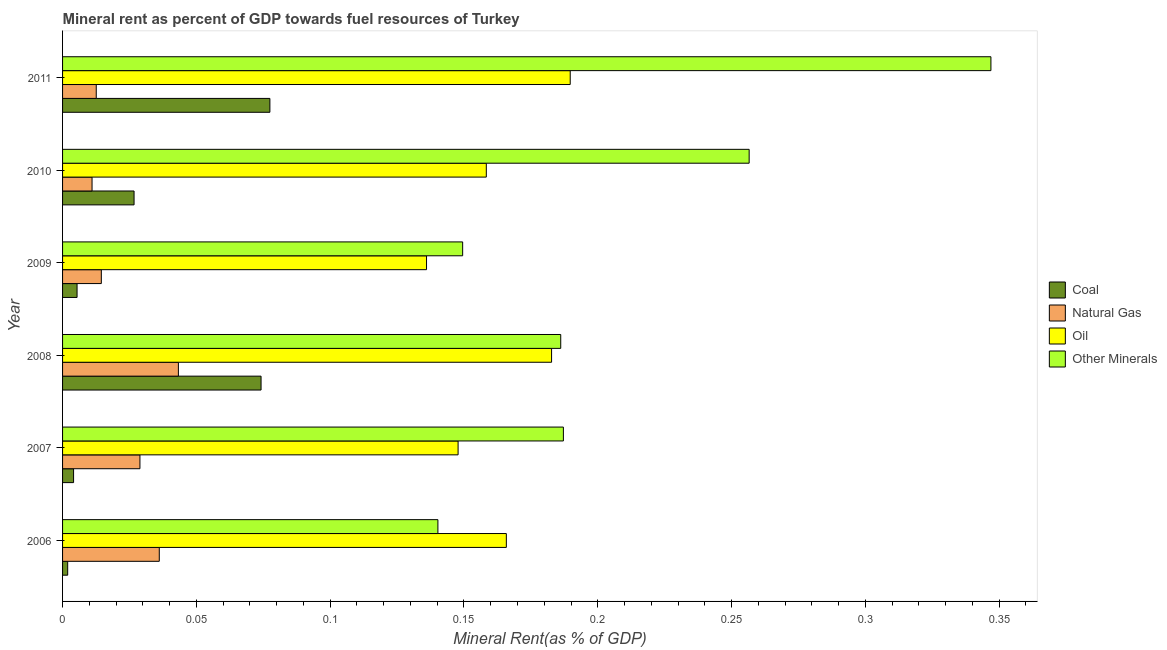How many different coloured bars are there?
Your answer should be very brief. 4. How many groups of bars are there?
Offer a terse response. 6. Are the number of bars per tick equal to the number of legend labels?
Give a very brief answer. Yes. Are the number of bars on each tick of the Y-axis equal?
Provide a short and direct response. Yes. How many bars are there on the 4th tick from the top?
Your answer should be very brief. 4. How many bars are there on the 3rd tick from the bottom?
Keep it short and to the point. 4. What is the  rent of other minerals in 2009?
Make the answer very short. 0.15. Across all years, what is the maximum coal rent?
Provide a succinct answer. 0.08. Across all years, what is the minimum  rent of other minerals?
Your answer should be compact. 0.14. In which year was the coal rent maximum?
Keep it short and to the point. 2011. What is the total coal rent in the graph?
Make the answer very short. 0.19. What is the difference between the oil rent in 2008 and that in 2011?
Keep it short and to the point. -0.01. What is the difference between the  rent of other minerals in 2009 and the coal rent in 2006?
Ensure brevity in your answer.  0.15. What is the average natural gas rent per year?
Keep it short and to the point. 0.02. In the year 2008, what is the difference between the  rent of other minerals and coal rent?
Ensure brevity in your answer.  0.11. What is the ratio of the coal rent in 2010 to that in 2011?
Offer a very short reply. 0.34. Is the coal rent in 2007 less than that in 2011?
Your answer should be very brief. Yes. What is the difference between the highest and the second highest  rent of other minerals?
Your response must be concise. 0.09. Is it the case that in every year, the sum of the coal rent and  rent of other minerals is greater than the sum of oil rent and natural gas rent?
Provide a succinct answer. No. What does the 3rd bar from the top in 2011 represents?
Offer a terse response. Natural Gas. What does the 1st bar from the bottom in 2011 represents?
Offer a terse response. Coal. How many bars are there?
Offer a very short reply. 24. Are all the bars in the graph horizontal?
Give a very brief answer. Yes. How many years are there in the graph?
Provide a short and direct response. 6. What is the difference between two consecutive major ticks on the X-axis?
Your answer should be compact. 0.05. Does the graph contain grids?
Ensure brevity in your answer.  No. Where does the legend appear in the graph?
Provide a succinct answer. Center right. How many legend labels are there?
Keep it short and to the point. 4. What is the title of the graph?
Your answer should be compact. Mineral rent as percent of GDP towards fuel resources of Turkey. What is the label or title of the X-axis?
Provide a short and direct response. Mineral Rent(as % of GDP). What is the Mineral Rent(as % of GDP) of Coal in 2006?
Offer a terse response. 0. What is the Mineral Rent(as % of GDP) in Natural Gas in 2006?
Offer a terse response. 0.04. What is the Mineral Rent(as % of GDP) of Oil in 2006?
Provide a short and direct response. 0.17. What is the Mineral Rent(as % of GDP) of Other Minerals in 2006?
Provide a succinct answer. 0.14. What is the Mineral Rent(as % of GDP) of Coal in 2007?
Offer a terse response. 0. What is the Mineral Rent(as % of GDP) in Natural Gas in 2007?
Make the answer very short. 0.03. What is the Mineral Rent(as % of GDP) in Oil in 2007?
Your answer should be very brief. 0.15. What is the Mineral Rent(as % of GDP) in Other Minerals in 2007?
Your response must be concise. 0.19. What is the Mineral Rent(as % of GDP) in Coal in 2008?
Provide a short and direct response. 0.07. What is the Mineral Rent(as % of GDP) of Natural Gas in 2008?
Your answer should be very brief. 0.04. What is the Mineral Rent(as % of GDP) of Oil in 2008?
Make the answer very short. 0.18. What is the Mineral Rent(as % of GDP) in Other Minerals in 2008?
Ensure brevity in your answer.  0.19. What is the Mineral Rent(as % of GDP) in Coal in 2009?
Give a very brief answer. 0.01. What is the Mineral Rent(as % of GDP) of Natural Gas in 2009?
Ensure brevity in your answer.  0.01. What is the Mineral Rent(as % of GDP) in Oil in 2009?
Make the answer very short. 0.14. What is the Mineral Rent(as % of GDP) of Other Minerals in 2009?
Your answer should be very brief. 0.15. What is the Mineral Rent(as % of GDP) in Coal in 2010?
Your answer should be compact. 0.03. What is the Mineral Rent(as % of GDP) in Natural Gas in 2010?
Make the answer very short. 0.01. What is the Mineral Rent(as % of GDP) in Oil in 2010?
Give a very brief answer. 0.16. What is the Mineral Rent(as % of GDP) in Other Minerals in 2010?
Make the answer very short. 0.26. What is the Mineral Rent(as % of GDP) in Coal in 2011?
Your answer should be very brief. 0.08. What is the Mineral Rent(as % of GDP) of Natural Gas in 2011?
Keep it short and to the point. 0.01. What is the Mineral Rent(as % of GDP) of Oil in 2011?
Make the answer very short. 0.19. What is the Mineral Rent(as % of GDP) of Other Minerals in 2011?
Your response must be concise. 0.35. Across all years, what is the maximum Mineral Rent(as % of GDP) of Coal?
Make the answer very short. 0.08. Across all years, what is the maximum Mineral Rent(as % of GDP) in Natural Gas?
Ensure brevity in your answer.  0.04. Across all years, what is the maximum Mineral Rent(as % of GDP) of Oil?
Offer a very short reply. 0.19. Across all years, what is the maximum Mineral Rent(as % of GDP) of Other Minerals?
Offer a very short reply. 0.35. Across all years, what is the minimum Mineral Rent(as % of GDP) of Coal?
Give a very brief answer. 0. Across all years, what is the minimum Mineral Rent(as % of GDP) in Natural Gas?
Your answer should be very brief. 0.01. Across all years, what is the minimum Mineral Rent(as % of GDP) of Oil?
Your answer should be very brief. 0.14. Across all years, what is the minimum Mineral Rent(as % of GDP) of Other Minerals?
Provide a succinct answer. 0.14. What is the total Mineral Rent(as % of GDP) of Coal in the graph?
Keep it short and to the point. 0.19. What is the total Mineral Rent(as % of GDP) in Natural Gas in the graph?
Make the answer very short. 0.15. What is the total Mineral Rent(as % of GDP) of Oil in the graph?
Provide a succinct answer. 0.98. What is the total Mineral Rent(as % of GDP) of Other Minerals in the graph?
Offer a very short reply. 1.27. What is the difference between the Mineral Rent(as % of GDP) of Coal in 2006 and that in 2007?
Your answer should be compact. -0. What is the difference between the Mineral Rent(as % of GDP) of Natural Gas in 2006 and that in 2007?
Your answer should be very brief. 0.01. What is the difference between the Mineral Rent(as % of GDP) of Oil in 2006 and that in 2007?
Ensure brevity in your answer.  0.02. What is the difference between the Mineral Rent(as % of GDP) of Other Minerals in 2006 and that in 2007?
Your answer should be compact. -0.05. What is the difference between the Mineral Rent(as % of GDP) of Coal in 2006 and that in 2008?
Provide a short and direct response. -0.07. What is the difference between the Mineral Rent(as % of GDP) of Natural Gas in 2006 and that in 2008?
Give a very brief answer. -0.01. What is the difference between the Mineral Rent(as % of GDP) of Oil in 2006 and that in 2008?
Keep it short and to the point. -0.02. What is the difference between the Mineral Rent(as % of GDP) in Other Minerals in 2006 and that in 2008?
Make the answer very short. -0.05. What is the difference between the Mineral Rent(as % of GDP) in Coal in 2006 and that in 2009?
Your answer should be very brief. -0. What is the difference between the Mineral Rent(as % of GDP) in Natural Gas in 2006 and that in 2009?
Your response must be concise. 0.02. What is the difference between the Mineral Rent(as % of GDP) of Oil in 2006 and that in 2009?
Ensure brevity in your answer.  0.03. What is the difference between the Mineral Rent(as % of GDP) of Other Minerals in 2006 and that in 2009?
Offer a very short reply. -0.01. What is the difference between the Mineral Rent(as % of GDP) in Coal in 2006 and that in 2010?
Your answer should be very brief. -0.02. What is the difference between the Mineral Rent(as % of GDP) of Natural Gas in 2006 and that in 2010?
Provide a short and direct response. 0.03. What is the difference between the Mineral Rent(as % of GDP) in Oil in 2006 and that in 2010?
Your response must be concise. 0.01. What is the difference between the Mineral Rent(as % of GDP) of Other Minerals in 2006 and that in 2010?
Provide a succinct answer. -0.12. What is the difference between the Mineral Rent(as % of GDP) in Coal in 2006 and that in 2011?
Make the answer very short. -0.08. What is the difference between the Mineral Rent(as % of GDP) in Natural Gas in 2006 and that in 2011?
Ensure brevity in your answer.  0.02. What is the difference between the Mineral Rent(as % of GDP) of Oil in 2006 and that in 2011?
Your response must be concise. -0.02. What is the difference between the Mineral Rent(as % of GDP) of Other Minerals in 2006 and that in 2011?
Make the answer very short. -0.21. What is the difference between the Mineral Rent(as % of GDP) of Coal in 2007 and that in 2008?
Keep it short and to the point. -0.07. What is the difference between the Mineral Rent(as % of GDP) of Natural Gas in 2007 and that in 2008?
Provide a short and direct response. -0.01. What is the difference between the Mineral Rent(as % of GDP) of Oil in 2007 and that in 2008?
Keep it short and to the point. -0.03. What is the difference between the Mineral Rent(as % of GDP) of Coal in 2007 and that in 2009?
Offer a very short reply. -0. What is the difference between the Mineral Rent(as % of GDP) of Natural Gas in 2007 and that in 2009?
Provide a short and direct response. 0.01. What is the difference between the Mineral Rent(as % of GDP) of Oil in 2007 and that in 2009?
Provide a short and direct response. 0.01. What is the difference between the Mineral Rent(as % of GDP) in Other Minerals in 2007 and that in 2009?
Your response must be concise. 0.04. What is the difference between the Mineral Rent(as % of GDP) of Coal in 2007 and that in 2010?
Keep it short and to the point. -0.02. What is the difference between the Mineral Rent(as % of GDP) of Natural Gas in 2007 and that in 2010?
Offer a very short reply. 0.02. What is the difference between the Mineral Rent(as % of GDP) of Oil in 2007 and that in 2010?
Ensure brevity in your answer.  -0.01. What is the difference between the Mineral Rent(as % of GDP) in Other Minerals in 2007 and that in 2010?
Keep it short and to the point. -0.07. What is the difference between the Mineral Rent(as % of GDP) in Coal in 2007 and that in 2011?
Your response must be concise. -0.07. What is the difference between the Mineral Rent(as % of GDP) in Natural Gas in 2007 and that in 2011?
Your answer should be very brief. 0.02. What is the difference between the Mineral Rent(as % of GDP) of Oil in 2007 and that in 2011?
Make the answer very short. -0.04. What is the difference between the Mineral Rent(as % of GDP) in Other Minerals in 2007 and that in 2011?
Make the answer very short. -0.16. What is the difference between the Mineral Rent(as % of GDP) of Coal in 2008 and that in 2009?
Your response must be concise. 0.07. What is the difference between the Mineral Rent(as % of GDP) of Natural Gas in 2008 and that in 2009?
Provide a succinct answer. 0.03. What is the difference between the Mineral Rent(as % of GDP) of Oil in 2008 and that in 2009?
Your answer should be very brief. 0.05. What is the difference between the Mineral Rent(as % of GDP) of Other Minerals in 2008 and that in 2009?
Make the answer very short. 0.04. What is the difference between the Mineral Rent(as % of GDP) in Coal in 2008 and that in 2010?
Your response must be concise. 0.05. What is the difference between the Mineral Rent(as % of GDP) in Natural Gas in 2008 and that in 2010?
Give a very brief answer. 0.03. What is the difference between the Mineral Rent(as % of GDP) in Oil in 2008 and that in 2010?
Your answer should be compact. 0.02. What is the difference between the Mineral Rent(as % of GDP) in Other Minerals in 2008 and that in 2010?
Your response must be concise. -0.07. What is the difference between the Mineral Rent(as % of GDP) of Coal in 2008 and that in 2011?
Make the answer very short. -0. What is the difference between the Mineral Rent(as % of GDP) in Natural Gas in 2008 and that in 2011?
Keep it short and to the point. 0.03. What is the difference between the Mineral Rent(as % of GDP) of Oil in 2008 and that in 2011?
Provide a succinct answer. -0.01. What is the difference between the Mineral Rent(as % of GDP) of Other Minerals in 2008 and that in 2011?
Provide a short and direct response. -0.16. What is the difference between the Mineral Rent(as % of GDP) in Coal in 2009 and that in 2010?
Provide a short and direct response. -0.02. What is the difference between the Mineral Rent(as % of GDP) of Natural Gas in 2009 and that in 2010?
Your answer should be compact. 0. What is the difference between the Mineral Rent(as % of GDP) in Oil in 2009 and that in 2010?
Offer a very short reply. -0.02. What is the difference between the Mineral Rent(as % of GDP) of Other Minerals in 2009 and that in 2010?
Your answer should be very brief. -0.11. What is the difference between the Mineral Rent(as % of GDP) of Coal in 2009 and that in 2011?
Provide a succinct answer. -0.07. What is the difference between the Mineral Rent(as % of GDP) of Natural Gas in 2009 and that in 2011?
Ensure brevity in your answer.  0. What is the difference between the Mineral Rent(as % of GDP) in Oil in 2009 and that in 2011?
Your answer should be compact. -0.05. What is the difference between the Mineral Rent(as % of GDP) of Other Minerals in 2009 and that in 2011?
Provide a short and direct response. -0.2. What is the difference between the Mineral Rent(as % of GDP) of Coal in 2010 and that in 2011?
Give a very brief answer. -0.05. What is the difference between the Mineral Rent(as % of GDP) of Natural Gas in 2010 and that in 2011?
Give a very brief answer. -0. What is the difference between the Mineral Rent(as % of GDP) in Oil in 2010 and that in 2011?
Offer a very short reply. -0.03. What is the difference between the Mineral Rent(as % of GDP) in Other Minerals in 2010 and that in 2011?
Give a very brief answer. -0.09. What is the difference between the Mineral Rent(as % of GDP) in Coal in 2006 and the Mineral Rent(as % of GDP) in Natural Gas in 2007?
Provide a short and direct response. -0.03. What is the difference between the Mineral Rent(as % of GDP) of Coal in 2006 and the Mineral Rent(as % of GDP) of Oil in 2007?
Provide a short and direct response. -0.15. What is the difference between the Mineral Rent(as % of GDP) of Coal in 2006 and the Mineral Rent(as % of GDP) of Other Minerals in 2007?
Offer a very short reply. -0.19. What is the difference between the Mineral Rent(as % of GDP) of Natural Gas in 2006 and the Mineral Rent(as % of GDP) of Oil in 2007?
Your answer should be very brief. -0.11. What is the difference between the Mineral Rent(as % of GDP) of Natural Gas in 2006 and the Mineral Rent(as % of GDP) of Other Minerals in 2007?
Your response must be concise. -0.15. What is the difference between the Mineral Rent(as % of GDP) of Oil in 2006 and the Mineral Rent(as % of GDP) of Other Minerals in 2007?
Offer a terse response. -0.02. What is the difference between the Mineral Rent(as % of GDP) in Coal in 2006 and the Mineral Rent(as % of GDP) in Natural Gas in 2008?
Ensure brevity in your answer.  -0.04. What is the difference between the Mineral Rent(as % of GDP) of Coal in 2006 and the Mineral Rent(as % of GDP) of Oil in 2008?
Your response must be concise. -0.18. What is the difference between the Mineral Rent(as % of GDP) of Coal in 2006 and the Mineral Rent(as % of GDP) of Other Minerals in 2008?
Make the answer very short. -0.18. What is the difference between the Mineral Rent(as % of GDP) in Natural Gas in 2006 and the Mineral Rent(as % of GDP) in Oil in 2008?
Offer a very short reply. -0.15. What is the difference between the Mineral Rent(as % of GDP) of Natural Gas in 2006 and the Mineral Rent(as % of GDP) of Other Minerals in 2008?
Your answer should be very brief. -0.15. What is the difference between the Mineral Rent(as % of GDP) in Oil in 2006 and the Mineral Rent(as % of GDP) in Other Minerals in 2008?
Your response must be concise. -0.02. What is the difference between the Mineral Rent(as % of GDP) in Coal in 2006 and the Mineral Rent(as % of GDP) in Natural Gas in 2009?
Offer a very short reply. -0.01. What is the difference between the Mineral Rent(as % of GDP) in Coal in 2006 and the Mineral Rent(as % of GDP) in Oil in 2009?
Offer a terse response. -0.13. What is the difference between the Mineral Rent(as % of GDP) of Coal in 2006 and the Mineral Rent(as % of GDP) of Other Minerals in 2009?
Offer a terse response. -0.15. What is the difference between the Mineral Rent(as % of GDP) in Natural Gas in 2006 and the Mineral Rent(as % of GDP) in Oil in 2009?
Provide a short and direct response. -0.1. What is the difference between the Mineral Rent(as % of GDP) in Natural Gas in 2006 and the Mineral Rent(as % of GDP) in Other Minerals in 2009?
Offer a terse response. -0.11. What is the difference between the Mineral Rent(as % of GDP) in Oil in 2006 and the Mineral Rent(as % of GDP) in Other Minerals in 2009?
Your answer should be very brief. 0.02. What is the difference between the Mineral Rent(as % of GDP) of Coal in 2006 and the Mineral Rent(as % of GDP) of Natural Gas in 2010?
Offer a very short reply. -0.01. What is the difference between the Mineral Rent(as % of GDP) of Coal in 2006 and the Mineral Rent(as % of GDP) of Oil in 2010?
Ensure brevity in your answer.  -0.16. What is the difference between the Mineral Rent(as % of GDP) of Coal in 2006 and the Mineral Rent(as % of GDP) of Other Minerals in 2010?
Provide a short and direct response. -0.25. What is the difference between the Mineral Rent(as % of GDP) of Natural Gas in 2006 and the Mineral Rent(as % of GDP) of Oil in 2010?
Give a very brief answer. -0.12. What is the difference between the Mineral Rent(as % of GDP) in Natural Gas in 2006 and the Mineral Rent(as % of GDP) in Other Minerals in 2010?
Keep it short and to the point. -0.22. What is the difference between the Mineral Rent(as % of GDP) of Oil in 2006 and the Mineral Rent(as % of GDP) of Other Minerals in 2010?
Keep it short and to the point. -0.09. What is the difference between the Mineral Rent(as % of GDP) in Coal in 2006 and the Mineral Rent(as % of GDP) in Natural Gas in 2011?
Ensure brevity in your answer.  -0.01. What is the difference between the Mineral Rent(as % of GDP) of Coal in 2006 and the Mineral Rent(as % of GDP) of Oil in 2011?
Your answer should be very brief. -0.19. What is the difference between the Mineral Rent(as % of GDP) in Coal in 2006 and the Mineral Rent(as % of GDP) in Other Minerals in 2011?
Your answer should be compact. -0.34. What is the difference between the Mineral Rent(as % of GDP) of Natural Gas in 2006 and the Mineral Rent(as % of GDP) of Oil in 2011?
Your answer should be compact. -0.15. What is the difference between the Mineral Rent(as % of GDP) of Natural Gas in 2006 and the Mineral Rent(as % of GDP) of Other Minerals in 2011?
Keep it short and to the point. -0.31. What is the difference between the Mineral Rent(as % of GDP) of Oil in 2006 and the Mineral Rent(as % of GDP) of Other Minerals in 2011?
Provide a succinct answer. -0.18. What is the difference between the Mineral Rent(as % of GDP) of Coal in 2007 and the Mineral Rent(as % of GDP) of Natural Gas in 2008?
Your answer should be very brief. -0.04. What is the difference between the Mineral Rent(as % of GDP) of Coal in 2007 and the Mineral Rent(as % of GDP) of Oil in 2008?
Provide a short and direct response. -0.18. What is the difference between the Mineral Rent(as % of GDP) of Coal in 2007 and the Mineral Rent(as % of GDP) of Other Minerals in 2008?
Offer a very short reply. -0.18. What is the difference between the Mineral Rent(as % of GDP) of Natural Gas in 2007 and the Mineral Rent(as % of GDP) of Oil in 2008?
Offer a terse response. -0.15. What is the difference between the Mineral Rent(as % of GDP) in Natural Gas in 2007 and the Mineral Rent(as % of GDP) in Other Minerals in 2008?
Keep it short and to the point. -0.16. What is the difference between the Mineral Rent(as % of GDP) in Oil in 2007 and the Mineral Rent(as % of GDP) in Other Minerals in 2008?
Offer a terse response. -0.04. What is the difference between the Mineral Rent(as % of GDP) in Coal in 2007 and the Mineral Rent(as % of GDP) in Natural Gas in 2009?
Provide a succinct answer. -0.01. What is the difference between the Mineral Rent(as % of GDP) of Coal in 2007 and the Mineral Rent(as % of GDP) of Oil in 2009?
Give a very brief answer. -0.13. What is the difference between the Mineral Rent(as % of GDP) in Coal in 2007 and the Mineral Rent(as % of GDP) in Other Minerals in 2009?
Provide a short and direct response. -0.15. What is the difference between the Mineral Rent(as % of GDP) of Natural Gas in 2007 and the Mineral Rent(as % of GDP) of Oil in 2009?
Offer a terse response. -0.11. What is the difference between the Mineral Rent(as % of GDP) of Natural Gas in 2007 and the Mineral Rent(as % of GDP) of Other Minerals in 2009?
Offer a very short reply. -0.12. What is the difference between the Mineral Rent(as % of GDP) of Oil in 2007 and the Mineral Rent(as % of GDP) of Other Minerals in 2009?
Provide a short and direct response. -0. What is the difference between the Mineral Rent(as % of GDP) of Coal in 2007 and the Mineral Rent(as % of GDP) of Natural Gas in 2010?
Give a very brief answer. -0.01. What is the difference between the Mineral Rent(as % of GDP) of Coal in 2007 and the Mineral Rent(as % of GDP) of Oil in 2010?
Provide a short and direct response. -0.15. What is the difference between the Mineral Rent(as % of GDP) of Coal in 2007 and the Mineral Rent(as % of GDP) of Other Minerals in 2010?
Offer a terse response. -0.25. What is the difference between the Mineral Rent(as % of GDP) in Natural Gas in 2007 and the Mineral Rent(as % of GDP) in Oil in 2010?
Ensure brevity in your answer.  -0.13. What is the difference between the Mineral Rent(as % of GDP) of Natural Gas in 2007 and the Mineral Rent(as % of GDP) of Other Minerals in 2010?
Offer a very short reply. -0.23. What is the difference between the Mineral Rent(as % of GDP) of Oil in 2007 and the Mineral Rent(as % of GDP) of Other Minerals in 2010?
Keep it short and to the point. -0.11. What is the difference between the Mineral Rent(as % of GDP) of Coal in 2007 and the Mineral Rent(as % of GDP) of Natural Gas in 2011?
Provide a short and direct response. -0.01. What is the difference between the Mineral Rent(as % of GDP) of Coal in 2007 and the Mineral Rent(as % of GDP) of Oil in 2011?
Keep it short and to the point. -0.19. What is the difference between the Mineral Rent(as % of GDP) of Coal in 2007 and the Mineral Rent(as % of GDP) of Other Minerals in 2011?
Provide a succinct answer. -0.34. What is the difference between the Mineral Rent(as % of GDP) of Natural Gas in 2007 and the Mineral Rent(as % of GDP) of Oil in 2011?
Provide a short and direct response. -0.16. What is the difference between the Mineral Rent(as % of GDP) of Natural Gas in 2007 and the Mineral Rent(as % of GDP) of Other Minerals in 2011?
Keep it short and to the point. -0.32. What is the difference between the Mineral Rent(as % of GDP) of Oil in 2007 and the Mineral Rent(as % of GDP) of Other Minerals in 2011?
Ensure brevity in your answer.  -0.2. What is the difference between the Mineral Rent(as % of GDP) of Coal in 2008 and the Mineral Rent(as % of GDP) of Natural Gas in 2009?
Keep it short and to the point. 0.06. What is the difference between the Mineral Rent(as % of GDP) in Coal in 2008 and the Mineral Rent(as % of GDP) in Oil in 2009?
Make the answer very short. -0.06. What is the difference between the Mineral Rent(as % of GDP) in Coal in 2008 and the Mineral Rent(as % of GDP) in Other Minerals in 2009?
Your answer should be compact. -0.08. What is the difference between the Mineral Rent(as % of GDP) of Natural Gas in 2008 and the Mineral Rent(as % of GDP) of Oil in 2009?
Offer a terse response. -0.09. What is the difference between the Mineral Rent(as % of GDP) in Natural Gas in 2008 and the Mineral Rent(as % of GDP) in Other Minerals in 2009?
Offer a very short reply. -0.11. What is the difference between the Mineral Rent(as % of GDP) in Oil in 2008 and the Mineral Rent(as % of GDP) in Other Minerals in 2009?
Give a very brief answer. 0.03. What is the difference between the Mineral Rent(as % of GDP) in Coal in 2008 and the Mineral Rent(as % of GDP) in Natural Gas in 2010?
Make the answer very short. 0.06. What is the difference between the Mineral Rent(as % of GDP) of Coal in 2008 and the Mineral Rent(as % of GDP) of Oil in 2010?
Offer a very short reply. -0.08. What is the difference between the Mineral Rent(as % of GDP) in Coal in 2008 and the Mineral Rent(as % of GDP) in Other Minerals in 2010?
Provide a short and direct response. -0.18. What is the difference between the Mineral Rent(as % of GDP) of Natural Gas in 2008 and the Mineral Rent(as % of GDP) of Oil in 2010?
Ensure brevity in your answer.  -0.12. What is the difference between the Mineral Rent(as % of GDP) of Natural Gas in 2008 and the Mineral Rent(as % of GDP) of Other Minerals in 2010?
Provide a short and direct response. -0.21. What is the difference between the Mineral Rent(as % of GDP) in Oil in 2008 and the Mineral Rent(as % of GDP) in Other Minerals in 2010?
Offer a very short reply. -0.07. What is the difference between the Mineral Rent(as % of GDP) in Coal in 2008 and the Mineral Rent(as % of GDP) in Natural Gas in 2011?
Offer a terse response. 0.06. What is the difference between the Mineral Rent(as % of GDP) in Coal in 2008 and the Mineral Rent(as % of GDP) in Oil in 2011?
Give a very brief answer. -0.12. What is the difference between the Mineral Rent(as % of GDP) in Coal in 2008 and the Mineral Rent(as % of GDP) in Other Minerals in 2011?
Make the answer very short. -0.27. What is the difference between the Mineral Rent(as % of GDP) in Natural Gas in 2008 and the Mineral Rent(as % of GDP) in Oil in 2011?
Your response must be concise. -0.15. What is the difference between the Mineral Rent(as % of GDP) of Natural Gas in 2008 and the Mineral Rent(as % of GDP) of Other Minerals in 2011?
Keep it short and to the point. -0.3. What is the difference between the Mineral Rent(as % of GDP) in Oil in 2008 and the Mineral Rent(as % of GDP) in Other Minerals in 2011?
Your answer should be compact. -0.16. What is the difference between the Mineral Rent(as % of GDP) of Coal in 2009 and the Mineral Rent(as % of GDP) of Natural Gas in 2010?
Your answer should be compact. -0.01. What is the difference between the Mineral Rent(as % of GDP) of Coal in 2009 and the Mineral Rent(as % of GDP) of Oil in 2010?
Offer a terse response. -0.15. What is the difference between the Mineral Rent(as % of GDP) in Coal in 2009 and the Mineral Rent(as % of GDP) in Other Minerals in 2010?
Provide a short and direct response. -0.25. What is the difference between the Mineral Rent(as % of GDP) of Natural Gas in 2009 and the Mineral Rent(as % of GDP) of Oil in 2010?
Provide a short and direct response. -0.14. What is the difference between the Mineral Rent(as % of GDP) of Natural Gas in 2009 and the Mineral Rent(as % of GDP) of Other Minerals in 2010?
Your response must be concise. -0.24. What is the difference between the Mineral Rent(as % of GDP) in Oil in 2009 and the Mineral Rent(as % of GDP) in Other Minerals in 2010?
Your answer should be compact. -0.12. What is the difference between the Mineral Rent(as % of GDP) of Coal in 2009 and the Mineral Rent(as % of GDP) of Natural Gas in 2011?
Your answer should be compact. -0.01. What is the difference between the Mineral Rent(as % of GDP) in Coal in 2009 and the Mineral Rent(as % of GDP) in Oil in 2011?
Your answer should be compact. -0.18. What is the difference between the Mineral Rent(as % of GDP) in Coal in 2009 and the Mineral Rent(as % of GDP) in Other Minerals in 2011?
Offer a terse response. -0.34. What is the difference between the Mineral Rent(as % of GDP) of Natural Gas in 2009 and the Mineral Rent(as % of GDP) of Oil in 2011?
Provide a succinct answer. -0.18. What is the difference between the Mineral Rent(as % of GDP) of Natural Gas in 2009 and the Mineral Rent(as % of GDP) of Other Minerals in 2011?
Your response must be concise. -0.33. What is the difference between the Mineral Rent(as % of GDP) in Oil in 2009 and the Mineral Rent(as % of GDP) in Other Minerals in 2011?
Make the answer very short. -0.21. What is the difference between the Mineral Rent(as % of GDP) in Coal in 2010 and the Mineral Rent(as % of GDP) in Natural Gas in 2011?
Your answer should be compact. 0.01. What is the difference between the Mineral Rent(as % of GDP) of Coal in 2010 and the Mineral Rent(as % of GDP) of Oil in 2011?
Offer a very short reply. -0.16. What is the difference between the Mineral Rent(as % of GDP) of Coal in 2010 and the Mineral Rent(as % of GDP) of Other Minerals in 2011?
Offer a very short reply. -0.32. What is the difference between the Mineral Rent(as % of GDP) of Natural Gas in 2010 and the Mineral Rent(as % of GDP) of Oil in 2011?
Keep it short and to the point. -0.18. What is the difference between the Mineral Rent(as % of GDP) of Natural Gas in 2010 and the Mineral Rent(as % of GDP) of Other Minerals in 2011?
Your answer should be very brief. -0.34. What is the difference between the Mineral Rent(as % of GDP) in Oil in 2010 and the Mineral Rent(as % of GDP) in Other Minerals in 2011?
Provide a short and direct response. -0.19. What is the average Mineral Rent(as % of GDP) in Coal per year?
Your response must be concise. 0.03. What is the average Mineral Rent(as % of GDP) of Natural Gas per year?
Your response must be concise. 0.02. What is the average Mineral Rent(as % of GDP) of Oil per year?
Offer a terse response. 0.16. What is the average Mineral Rent(as % of GDP) of Other Minerals per year?
Give a very brief answer. 0.21. In the year 2006, what is the difference between the Mineral Rent(as % of GDP) of Coal and Mineral Rent(as % of GDP) of Natural Gas?
Make the answer very short. -0.03. In the year 2006, what is the difference between the Mineral Rent(as % of GDP) of Coal and Mineral Rent(as % of GDP) of Oil?
Provide a succinct answer. -0.16. In the year 2006, what is the difference between the Mineral Rent(as % of GDP) in Coal and Mineral Rent(as % of GDP) in Other Minerals?
Your answer should be compact. -0.14. In the year 2006, what is the difference between the Mineral Rent(as % of GDP) of Natural Gas and Mineral Rent(as % of GDP) of Oil?
Your response must be concise. -0.13. In the year 2006, what is the difference between the Mineral Rent(as % of GDP) in Natural Gas and Mineral Rent(as % of GDP) in Other Minerals?
Your answer should be compact. -0.1. In the year 2006, what is the difference between the Mineral Rent(as % of GDP) of Oil and Mineral Rent(as % of GDP) of Other Minerals?
Your response must be concise. 0.03. In the year 2007, what is the difference between the Mineral Rent(as % of GDP) of Coal and Mineral Rent(as % of GDP) of Natural Gas?
Offer a terse response. -0.02. In the year 2007, what is the difference between the Mineral Rent(as % of GDP) in Coal and Mineral Rent(as % of GDP) in Oil?
Give a very brief answer. -0.14. In the year 2007, what is the difference between the Mineral Rent(as % of GDP) in Coal and Mineral Rent(as % of GDP) in Other Minerals?
Your response must be concise. -0.18. In the year 2007, what is the difference between the Mineral Rent(as % of GDP) in Natural Gas and Mineral Rent(as % of GDP) in Oil?
Ensure brevity in your answer.  -0.12. In the year 2007, what is the difference between the Mineral Rent(as % of GDP) in Natural Gas and Mineral Rent(as % of GDP) in Other Minerals?
Ensure brevity in your answer.  -0.16. In the year 2007, what is the difference between the Mineral Rent(as % of GDP) of Oil and Mineral Rent(as % of GDP) of Other Minerals?
Keep it short and to the point. -0.04. In the year 2008, what is the difference between the Mineral Rent(as % of GDP) of Coal and Mineral Rent(as % of GDP) of Natural Gas?
Provide a short and direct response. 0.03. In the year 2008, what is the difference between the Mineral Rent(as % of GDP) in Coal and Mineral Rent(as % of GDP) in Oil?
Ensure brevity in your answer.  -0.11. In the year 2008, what is the difference between the Mineral Rent(as % of GDP) of Coal and Mineral Rent(as % of GDP) of Other Minerals?
Ensure brevity in your answer.  -0.11. In the year 2008, what is the difference between the Mineral Rent(as % of GDP) in Natural Gas and Mineral Rent(as % of GDP) in Oil?
Keep it short and to the point. -0.14. In the year 2008, what is the difference between the Mineral Rent(as % of GDP) of Natural Gas and Mineral Rent(as % of GDP) of Other Minerals?
Your response must be concise. -0.14. In the year 2008, what is the difference between the Mineral Rent(as % of GDP) in Oil and Mineral Rent(as % of GDP) in Other Minerals?
Give a very brief answer. -0. In the year 2009, what is the difference between the Mineral Rent(as % of GDP) of Coal and Mineral Rent(as % of GDP) of Natural Gas?
Provide a succinct answer. -0.01. In the year 2009, what is the difference between the Mineral Rent(as % of GDP) in Coal and Mineral Rent(as % of GDP) in Oil?
Your answer should be compact. -0.13. In the year 2009, what is the difference between the Mineral Rent(as % of GDP) of Coal and Mineral Rent(as % of GDP) of Other Minerals?
Provide a succinct answer. -0.14. In the year 2009, what is the difference between the Mineral Rent(as % of GDP) in Natural Gas and Mineral Rent(as % of GDP) in Oil?
Provide a short and direct response. -0.12. In the year 2009, what is the difference between the Mineral Rent(as % of GDP) of Natural Gas and Mineral Rent(as % of GDP) of Other Minerals?
Provide a succinct answer. -0.14. In the year 2009, what is the difference between the Mineral Rent(as % of GDP) in Oil and Mineral Rent(as % of GDP) in Other Minerals?
Provide a short and direct response. -0.01. In the year 2010, what is the difference between the Mineral Rent(as % of GDP) in Coal and Mineral Rent(as % of GDP) in Natural Gas?
Provide a succinct answer. 0.02. In the year 2010, what is the difference between the Mineral Rent(as % of GDP) of Coal and Mineral Rent(as % of GDP) of Oil?
Provide a short and direct response. -0.13. In the year 2010, what is the difference between the Mineral Rent(as % of GDP) of Coal and Mineral Rent(as % of GDP) of Other Minerals?
Offer a terse response. -0.23. In the year 2010, what is the difference between the Mineral Rent(as % of GDP) in Natural Gas and Mineral Rent(as % of GDP) in Oil?
Your answer should be very brief. -0.15. In the year 2010, what is the difference between the Mineral Rent(as % of GDP) in Natural Gas and Mineral Rent(as % of GDP) in Other Minerals?
Your answer should be compact. -0.25. In the year 2010, what is the difference between the Mineral Rent(as % of GDP) of Oil and Mineral Rent(as % of GDP) of Other Minerals?
Make the answer very short. -0.1. In the year 2011, what is the difference between the Mineral Rent(as % of GDP) of Coal and Mineral Rent(as % of GDP) of Natural Gas?
Keep it short and to the point. 0.06. In the year 2011, what is the difference between the Mineral Rent(as % of GDP) in Coal and Mineral Rent(as % of GDP) in Oil?
Provide a succinct answer. -0.11. In the year 2011, what is the difference between the Mineral Rent(as % of GDP) of Coal and Mineral Rent(as % of GDP) of Other Minerals?
Provide a short and direct response. -0.27. In the year 2011, what is the difference between the Mineral Rent(as % of GDP) of Natural Gas and Mineral Rent(as % of GDP) of Oil?
Keep it short and to the point. -0.18. In the year 2011, what is the difference between the Mineral Rent(as % of GDP) in Natural Gas and Mineral Rent(as % of GDP) in Other Minerals?
Offer a terse response. -0.33. In the year 2011, what is the difference between the Mineral Rent(as % of GDP) of Oil and Mineral Rent(as % of GDP) of Other Minerals?
Provide a short and direct response. -0.16. What is the ratio of the Mineral Rent(as % of GDP) of Coal in 2006 to that in 2007?
Make the answer very short. 0.46. What is the ratio of the Mineral Rent(as % of GDP) of Natural Gas in 2006 to that in 2007?
Keep it short and to the point. 1.25. What is the ratio of the Mineral Rent(as % of GDP) of Oil in 2006 to that in 2007?
Provide a succinct answer. 1.12. What is the ratio of the Mineral Rent(as % of GDP) of Other Minerals in 2006 to that in 2007?
Keep it short and to the point. 0.75. What is the ratio of the Mineral Rent(as % of GDP) in Coal in 2006 to that in 2008?
Offer a very short reply. 0.03. What is the ratio of the Mineral Rent(as % of GDP) in Natural Gas in 2006 to that in 2008?
Provide a succinct answer. 0.83. What is the ratio of the Mineral Rent(as % of GDP) of Oil in 2006 to that in 2008?
Make the answer very short. 0.91. What is the ratio of the Mineral Rent(as % of GDP) in Other Minerals in 2006 to that in 2008?
Offer a terse response. 0.75. What is the ratio of the Mineral Rent(as % of GDP) of Coal in 2006 to that in 2009?
Provide a short and direct response. 0.35. What is the ratio of the Mineral Rent(as % of GDP) of Natural Gas in 2006 to that in 2009?
Offer a very short reply. 2.49. What is the ratio of the Mineral Rent(as % of GDP) of Oil in 2006 to that in 2009?
Make the answer very short. 1.22. What is the ratio of the Mineral Rent(as % of GDP) of Other Minerals in 2006 to that in 2009?
Provide a succinct answer. 0.94. What is the ratio of the Mineral Rent(as % of GDP) of Coal in 2006 to that in 2010?
Keep it short and to the point. 0.07. What is the ratio of the Mineral Rent(as % of GDP) of Natural Gas in 2006 to that in 2010?
Provide a short and direct response. 3.28. What is the ratio of the Mineral Rent(as % of GDP) of Oil in 2006 to that in 2010?
Provide a succinct answer. 1.05. What is the ratio of the Mineral Rent(as % of GDP) of Other Minerals in 2006 to that in 2010?
Provide a short and direct response. 0.55. What is the ratio of the Mineral Rent(as % of GDP) of Coal in 2006 to that in 2011?
Your answer should be very brief. 0.02. What is the ratio of the Mineral Rent(as % of GDP) in Natural Gas in 2006 to that in 2011?
Your answer should be very brief. 2.87. What is the ratio of the Mineral Rent(as % of GDP) of Oil in 2006 to that in 2011?
Give a very brief answer. 0.87. What is the ratio of the Mineral Rent(as % of GDP) of Other Minerals in 2006 to that in 2011?
Provide a succinct answer. 0.4. What is the ratio of the Mineral Rent(as % of GDP) in Coal in 2007 to that in 2008?
Provide a short and direct response. 0.06. What is the ratio of the Mineral Rent(as % of GDP) of Natural Gas in 2007 to that in 2008?
Offer a very short reply. 0.67. What is the ratio of the Mineral Rent(as % of GDP) in Oil in 2007 to that in 2008?
Ensure brevity in your answer.  0.81. What is the ratio of the Mineral Rent(as % of GDP) in Coal in 2007 to that in 2009?
Offer a terse response. 0.76. What is the ratio of the Mineral Rent(as % of GDP) of Natural Gas in 2007 to that in 2009?
Provide a short and direct response. 2. What is the ratio of the Mineral Rent(as % of GDP) of Oil in 2007 to that in 2009?
Your answer should be very brief. 1.09. What is the ratio of the Mineral Rent(as % of GDP) in Other Minerals in 2007 to that in 2009?
Your answer should be very brief. 1.25. What is the ratio of the Mineral Rent(as % of GDP) in Coal in 2007 to that in 2010?
Make the answer very short. 0.15. What is the ratio of the Mineral Rent(as % of GDP) of Natural Gas in 2007 to that in 2010?
Give a very brief answer. 2.62. What is the ratio of the Mineral Rent(as % of GDP) in Oil in 2007 to that in 2010?
Keep it short and to the point. 0.93. What is the ratio of the Mineral Rent(as % of GDP) in Other Minerals in 2007 to that in 2010?
Your response must be concise. 0.73. What is the ratio of the Mineral Rent(as % of GDP) in Coal in 2007 to that in 2011?
Make the answer very short. 0.05. What is the ratio of the Mineral Rent(as % of GDP) in Natural Gas in 2007 to that in 2011?
Your response must be concise. 2.3. What is the ratio of the Mineral Rent(as % of GDP) in Oil in 2007 to that in 2011?
Provide a succinct answer. 0.78. What is the ratio of the Mineral Rent(as % of GDP) of Other Minerals in 2007 to that in 2011?
Ensure brevity in your answer.  0.54. What is the ratio of the Mineral Rent(as % of GDP) in Coal in 2008 to that in 2009?
Ensure brevity in your answer.  13.69. What is the ratio of the Mineral Rent(as % of GDP) of Natural Gas in 2008 to that in 2009?
Offer a terse response. 2.99. What is the ratio of the Mineral Rent(as % of GDP) of Oil in 2008 to that in 2009?
Provide a succinct answer. 1.34. What is the ratio of the Mineral Rent(as % of GDP) in Other Minerals in 2008 to that in 2009?
Your response must be concise. 1.25. What is the ratio of the Mineral Rent(as % of GDP) in Coal in 2008 to that in 2010?
Offer a very short reply. 2.78. What is the ratio of the Mineral Rent(as % of GDP) of Natural Gas in 2008 to that in 2010?
Ensure brevity in your answer.  3.93. What is the ratio of the Mineral Rent(as % of GDP) of Oil in 2008 to that in 2010?
Offer a terse response. 1.15. What is the ratio of the Mineral Rent(as % of GDP) of Other Minerals in 2008 to that in 2010?
Keep it short and to the point. 0.73. What is the ratio of the Mineral Rent(as % of GDP) of Coal in 2008 to that in 2011?
Provide a succinct answer. 0.96. What is the ratio of the Mineral Rent(as % of GDP) of Natural Gas in 2008 to that in 2011?
Offer a very short reply. 3.44. What is the ratio of the Mineral Rent(as % of GDP) in Oil in 2008 to that in 2011?
Ensure brevity in your answer.  0.96. What is the ratio of the Mineral Rent(as % of GDP) of Other Minerals in 2008 to that in 2011?
Your answer should be compact. 0.54. What is the ratio of the Mineral Rent(as % of GDP) of Coal in 2009 to that in 2010?
Your response must be concise. 0.2. What is the ratio of the Mineral Rent(as % of GDP) of Natural Gas in 2009 to that in 2010?
Make the answer very short. 1.31. What is the ratio of the Mineral Rent(as % of GDP) of Oil in 2009 to that in 2010?
Give a very brief answer. 0.86. What is the ratio of the Mineral Rent(as % of GDP) of Other Minerals in 2009 to that in 2010?
Your answer should be compact. 0.58. What is the ratio of the Mineral Rent(as % of GDP) in Coal in 2009 to that in 2011?
Provide a short and direct response. 0.07. What is the ratio of the Mineral Rent(as % of GDP) in Natural Gas in 2009 to that in 2011?
Provide a succinct answer. 1.15. What is the ratio of the Mineral Rent(as % of GDP) of Oil in 2009 to that in 2011?
Offer a terse response. 0.72. What is the ratio of the Mineral Rent(as % of GDP) in Other Minerals in 2009 to that in 2011?
Your response must be concise. 0.43. What is the ratio of the Mineral Rent(as % of GDP) of Coal in 2010 to that in 2011?
Offer a terse response. 0.34. What is the ratio of the Mineral Rent(as % of GDP) of Natural Gas in 2010 to that in 2011?
Keep it short and to the point. 0.88. What is the ratio of the Mineral Rent(as % of GDP) in Oil in 2010 to that in 2011?
Provide a short and direct response. 0.83. What is the ratio of the Mineral Rent(as % of GDP) of Other Minerals in 2010 to that in 2011?
Make the answer very short. 0.74. What is the difference between the highest and the second highest Mineral Rent(as % of GDP) of Coal?
Make the answer very short. 0. What is the difference between the highest and the second highest Mineral Rent(as % of GDP) of Natural Gas?
Make the answer very short. 0.01. What is the difference between the highest and the second highest Mineral Rent(as % of GDP) of Oil?
Give a very brief answer. 0.01. What is the difference between the highest and the second highest Mineral Rent(as % of GDP) of Other Minerals?
Ensure brevity in your answer.  0.09. What is the difference between the highest and the lowest Mineral Rent(as % of GDP) in Coal?
Ensure brevity in your answer.  0.08. What is the difference between the highest and the lowest Mineral Rent(as % of GDP) of Natural Gas?
Your response must be concise. 0.03. What is the difference between the highest and the lowest Mineral Rent(as % of GDP) of Oil?
Make the answer very short. 0.05. What is the difference between the highest and the lowest Mineral Rent(as % of GDP) in Other Minerals?
Your answer should be very brief. 0.21. 